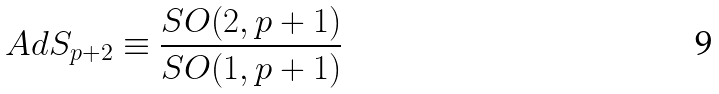Convert formula to latex. <formula><loc_0><loc_0><loc_500><loc_500>A d S _ { p + 2 } \equiv \frac { S O ( 2 , p + 1 ) } { S O ( 1 , p + 1 ) }</formula> 